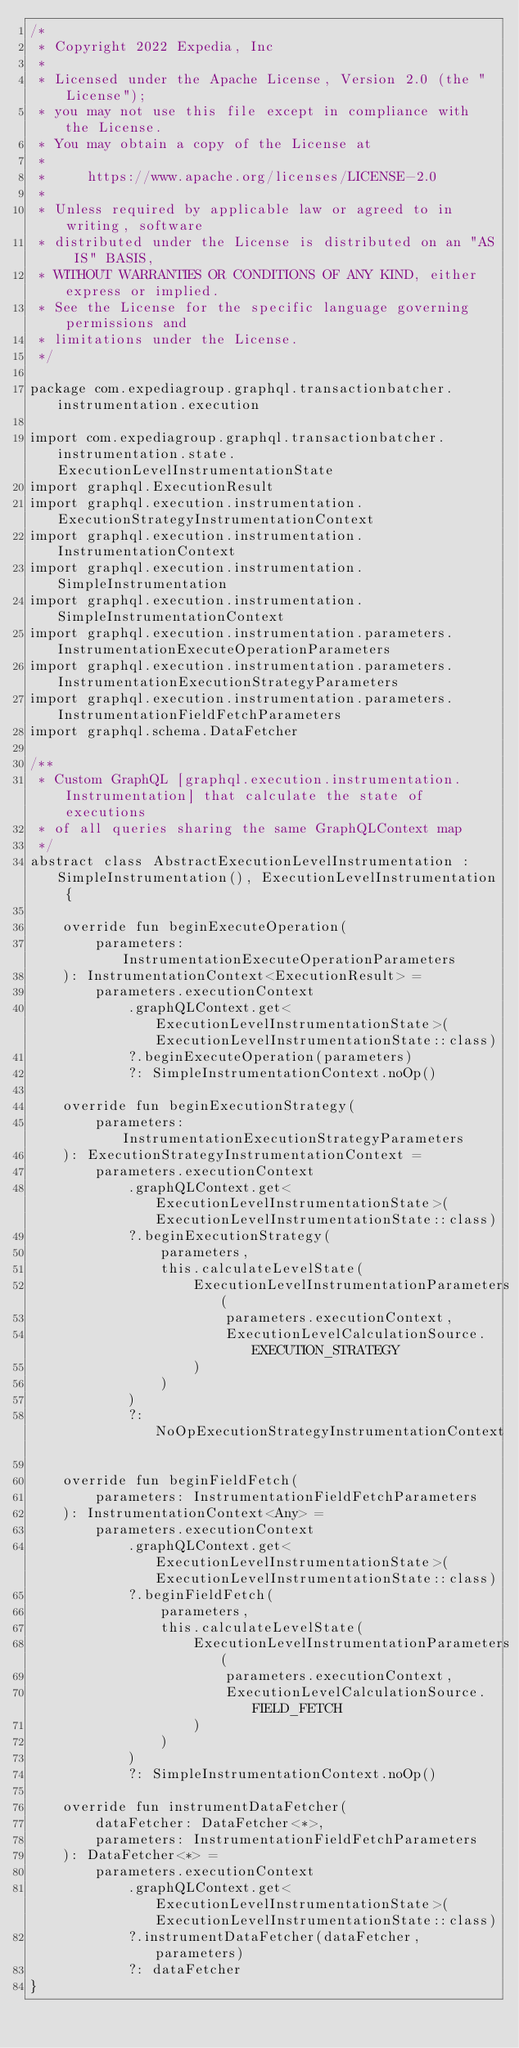Convert code to text. <code><loc_0><loc_0><loc_500><loc_500><_Kotlin_>/*
 * Copyright 2022 Expedia, Inc
 *
 * Licensed under the Apache License, Version 2.0 (the "License");
 * you may not use this file except in compliance with the License.
 * You may obtain a copy of the License at
 *
 *     https://www.apache.org/licenses/LICENSE-2.0
 *
 * Unless required by applicable law or agreed to in writing, software
 * distributed under the License is distributed on an "AS IS" BASIS,
 * WITHOUT WARRANTIES OR CONDITIONS OF ANY KIND, either express or implied.
 * See the License for the specific language governing permissions and
 * limitations under the License.
 */

package com.expediagroup.graphql.transactionbatcher.instrumentation.execution

import com.expediagroup.graphql.transactionbatcher.instrumentation.state.ExecutionLevelInstrumentationState
import graphql.ExecutionResult
import graphql.execution.instrumentation.ExecutionStrategyInstrumentationContext
import graphql.execution.instrumentation.InstrumentationContext
import graphql.execution.instrumentation.SimpleInstrumentation
import graphql.execution.instrumentation.SimpleInstrumentationContext
import graphql.execution.instrumentation.parameters.InstrumentationExecuteOperationParameters
import graphql.execution.instrumentation.parameters.InstrumentationExecutionStrategyParameters
import graphql.execution.instrumentation.parameters.InstrumentationFieldFetchParameters
import graphql.schema.DataFetcher

/**
 * Custom GraphQL [graphql.execution.instrumentation.Instrumentation] that calculate the state of executions
 * of all queries sharing the same GraphQLContext map
 */
abstract class AbstractExecutionLevelInstrumentation : SimpleInstrumentation(), ExecutionLevelInstrumentation {

    override fun beginExecuteOperation(
        parameters: InstrumentationExecuteOperationParameters
    ): InstrumentationContext<ExecutionResult> =
        parameters.executionContext
            .graphQLContext.get<ExecutionLevelInstrumentationState>(ExecutionLevelInstrumentationState::class)
            ?.beginExecuteOperation(parameters)
            ?: SimpleInstrumentationContext.noOp()

    override fun beginExecutionStrategy(
        parameters: InstrumentationExecutionStrategyParameters
    ): ExecutionStrategyInstrumentationContext =
        parameters.executionContext
            .graphQLContext.get<ExecutionLevelInstrumentationState>(ExecutionLevelInstrumentationState::class)
            ?.beginExecutionStrategy(
                parameters,
                this.calculateLevelState(
                    ExecutionLevelInstrumentationParameters(
                        parameters.executionContext,
                        ExecutionLevelCalculationSource.EXECUTION_STRATEGY
                    )
                )
            )
            ?: NoOpExecutionStrategyInstrumentationContext

    override fun beginFieldFetch(
        parameters: InstrumentationFieldFetchParameters
    ): InstrumentationContext<Any> =
        parameters.executionContext
            .graphQLContext.get<ExecutionLevelInstrumentationState>(ExecutionLevelInstrumentationState::class)
            ?.beginFieldFetch(
                parameters,
                this.calculateLevelState(
                    ExecutionLevelInstrumentationParameters(
                        parameters.executionContext,
                        ExecutionLevelCalculationSource.FIELD_FETCH
                    )
                )
            )
            ?: SimpleInstrumentationContext.noOp()

    override fun instrumentDataFetcher(
        dataFetcher: DataFetcher<*>,
        parameters: InstrumentationFieldFetchParameters
    ): DataFetcher<*> =
        parameters.executionContext
            .graphQLContext.get<ExecutionLevelInstrumentationState>(ExecutionLevelInstrumentationState::class)
            ?.instrumentDataFetcher(dataFetcher, parameters)
            ?: dataFetcher
}
</code> 